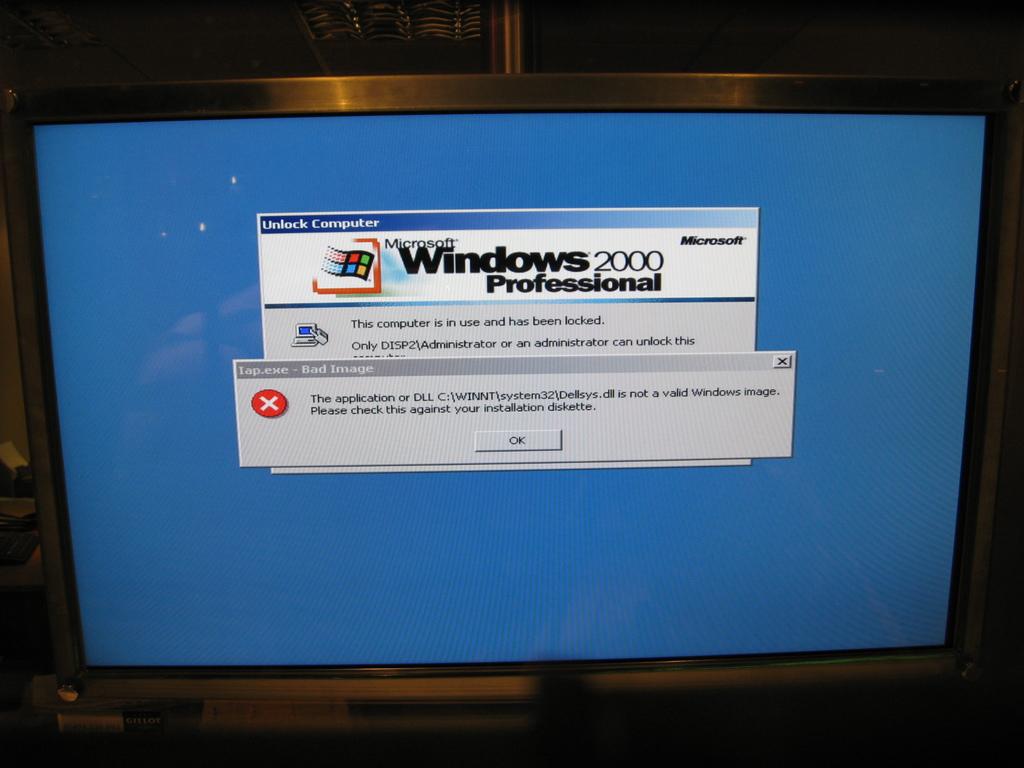What os system does this compuer use?
Provide a short and direct response. Windows 2000. 